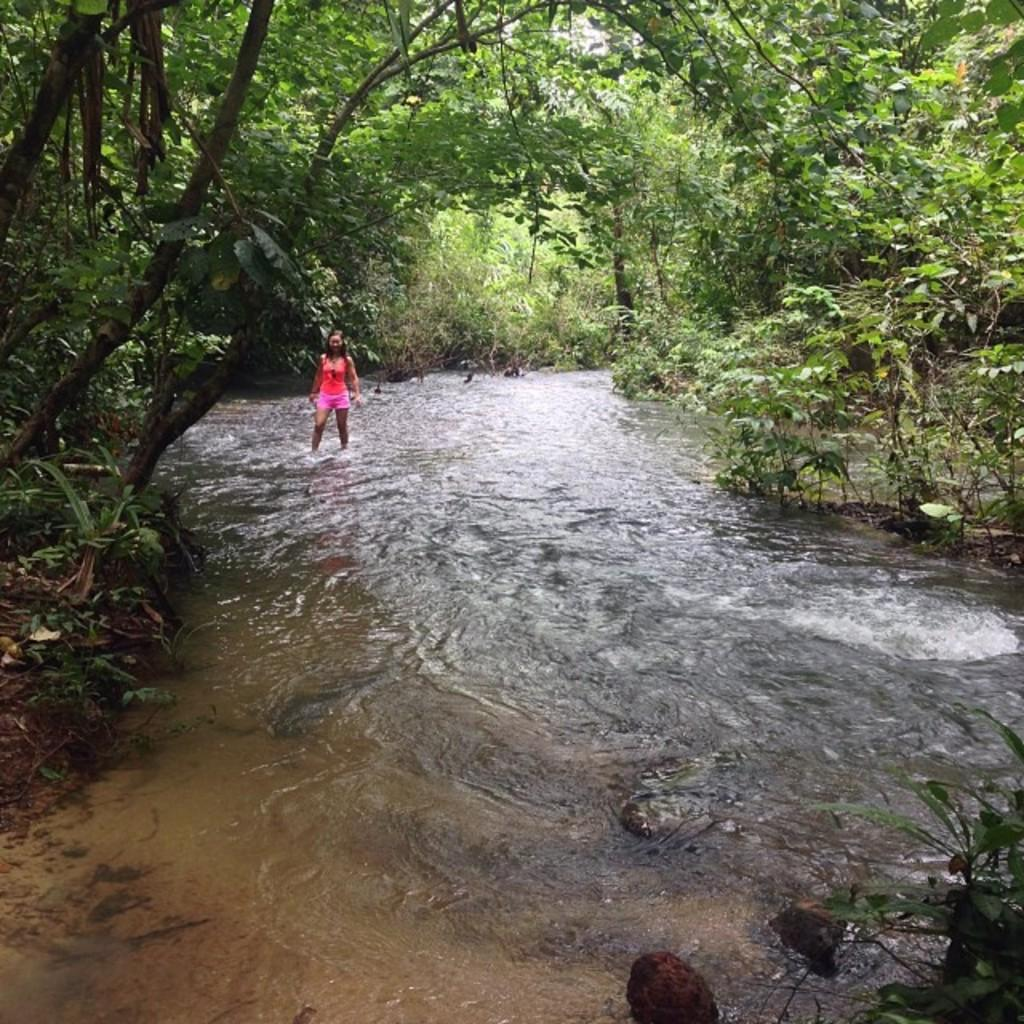Who is present in the image? There is a woman in the image. What is the woman doing in the image? The woman is standing in the water. What can be seen in the background of the image? There are trees visible in the image. What is the chance of the woman catching a cold in the image? There is no information about the weather or temperature in the image, so it is impossible to determine the chance of the woman catching a cold. 